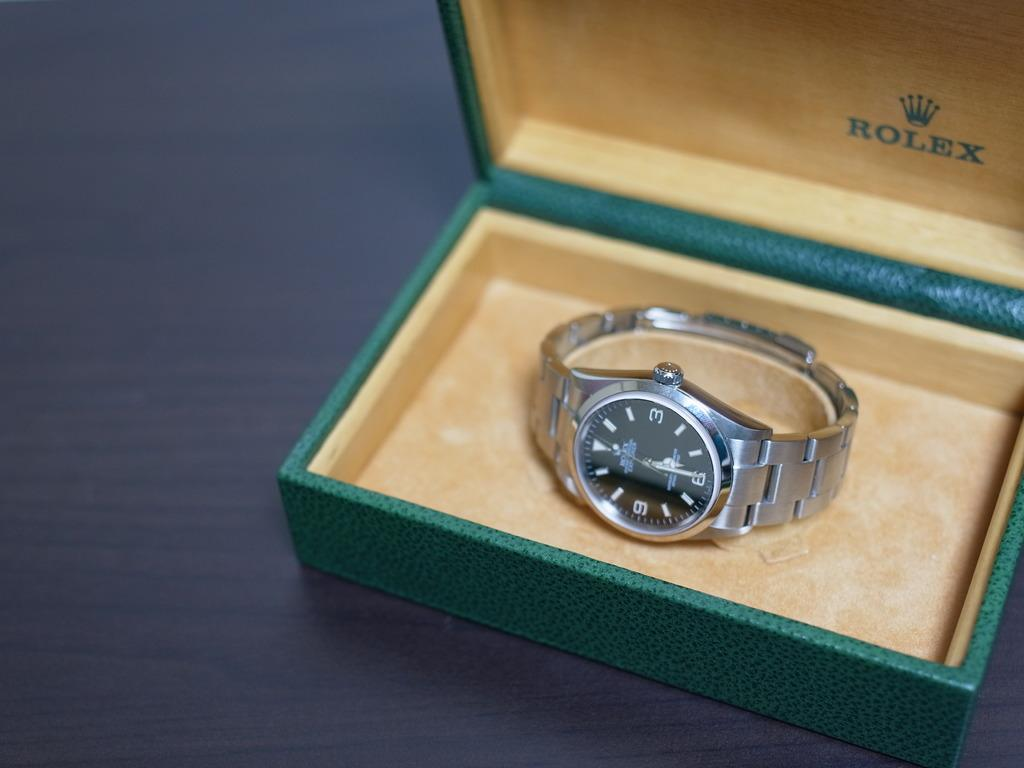<image>
Summarize the visual content of the image. A silver tone Rolex wristwatch in a velvet lined green gift box. 